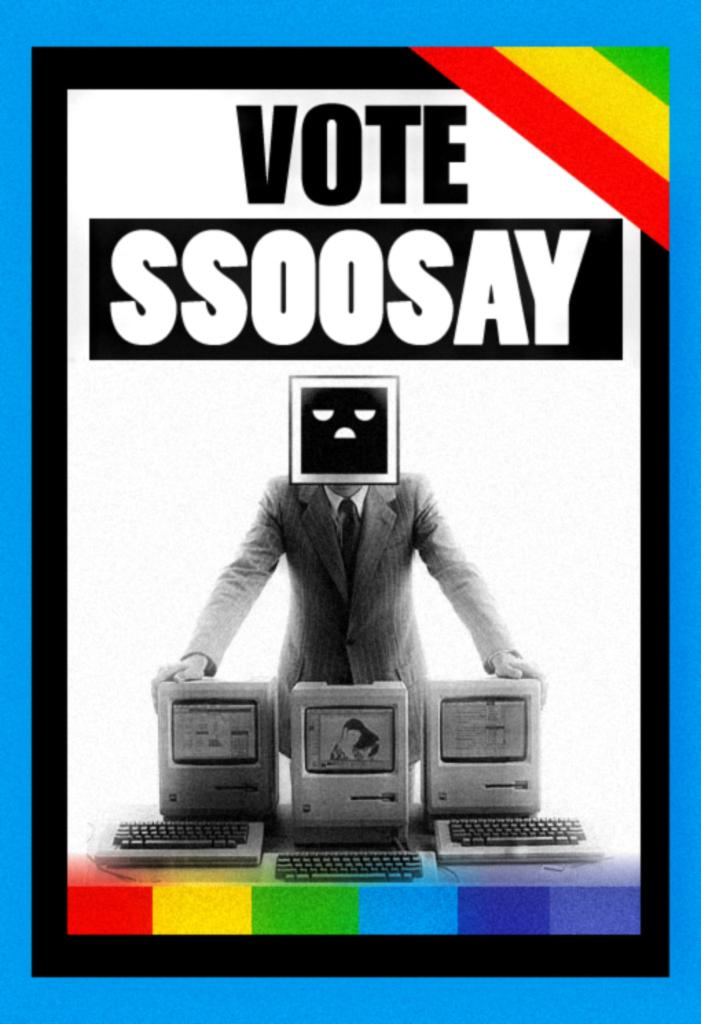What can be seen in the image? There is a poster in the image. What type of advice is given by the yarn in the image? There is no yarn present in the image, and therefore no advice can be given by it. 